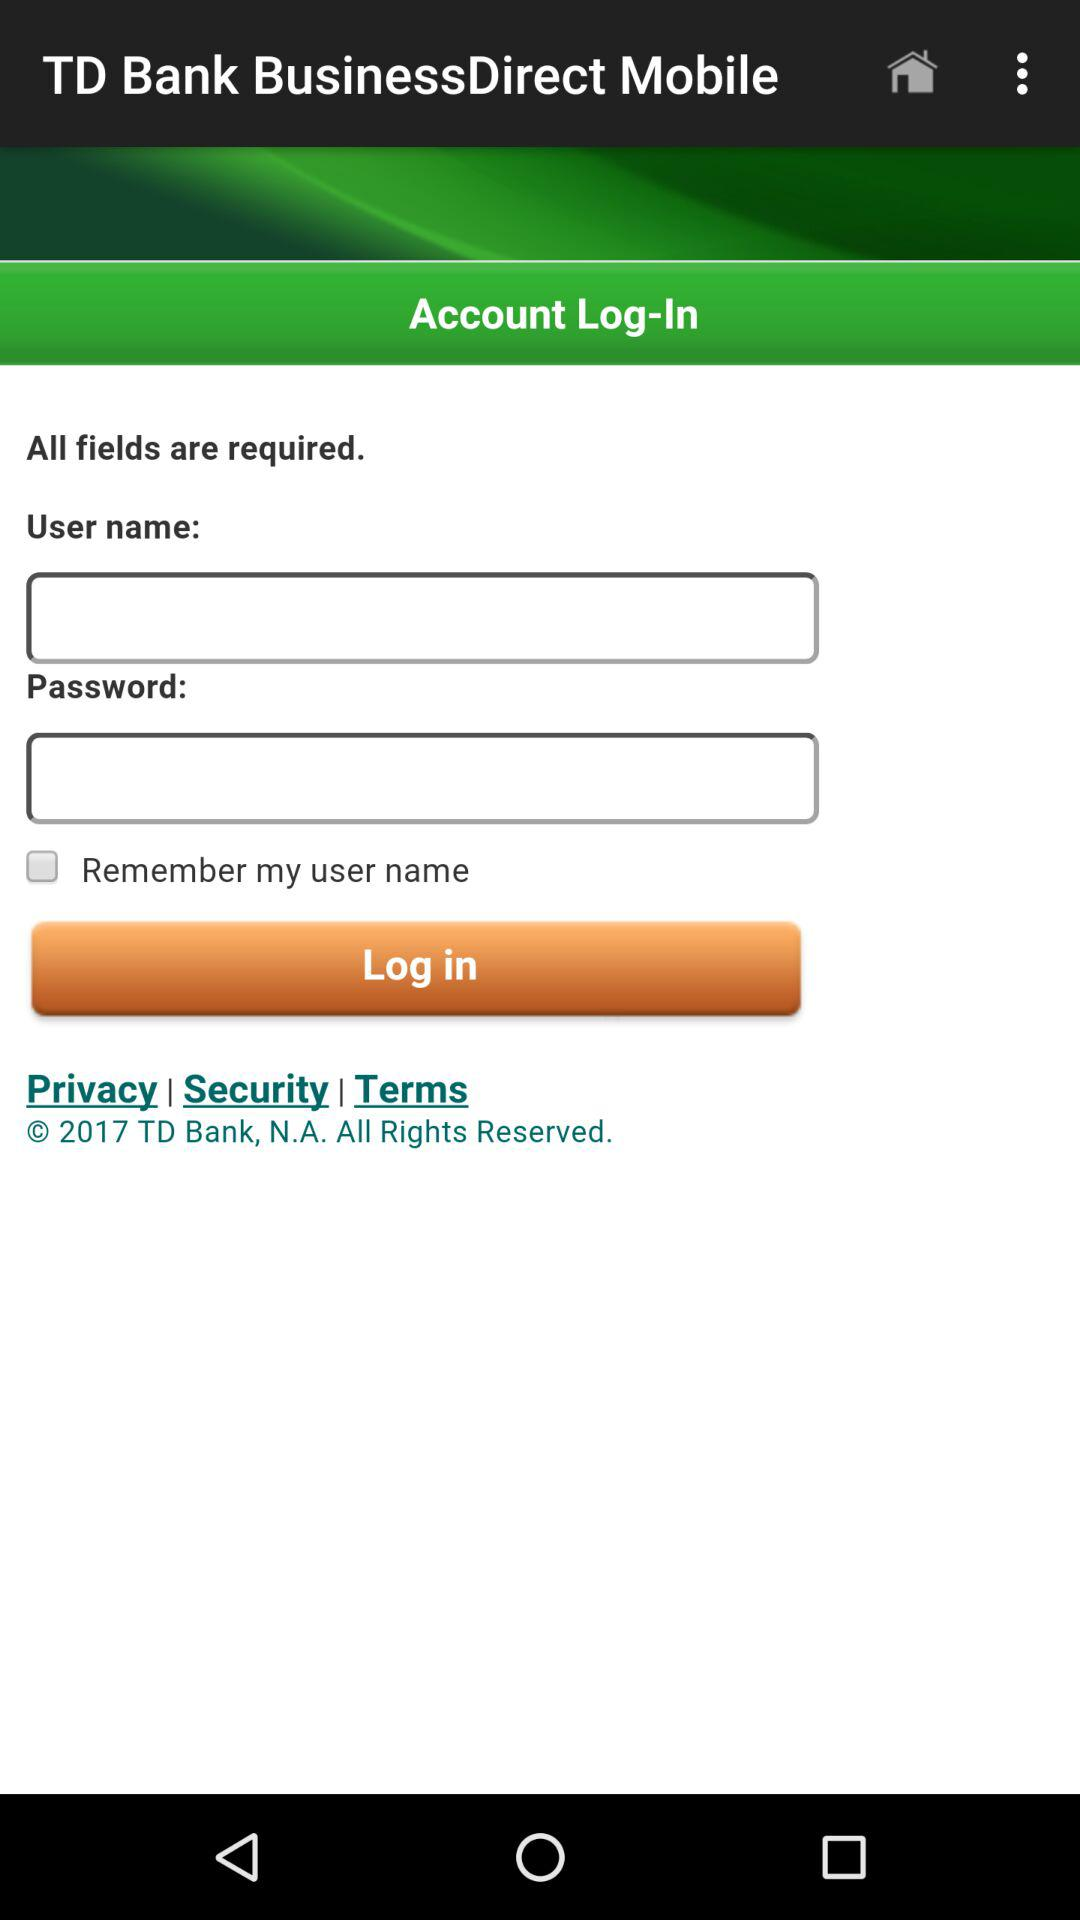How can we log in? You can log in with a user name and password. 